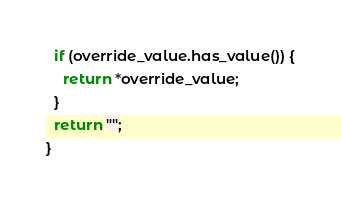Convert code to text. <code><loc_0><loc_0><loc_500><loc_500><_C++_>  if (override_value.has_value()) {
    return *override_value;
  }
  return "";
}
</code> 